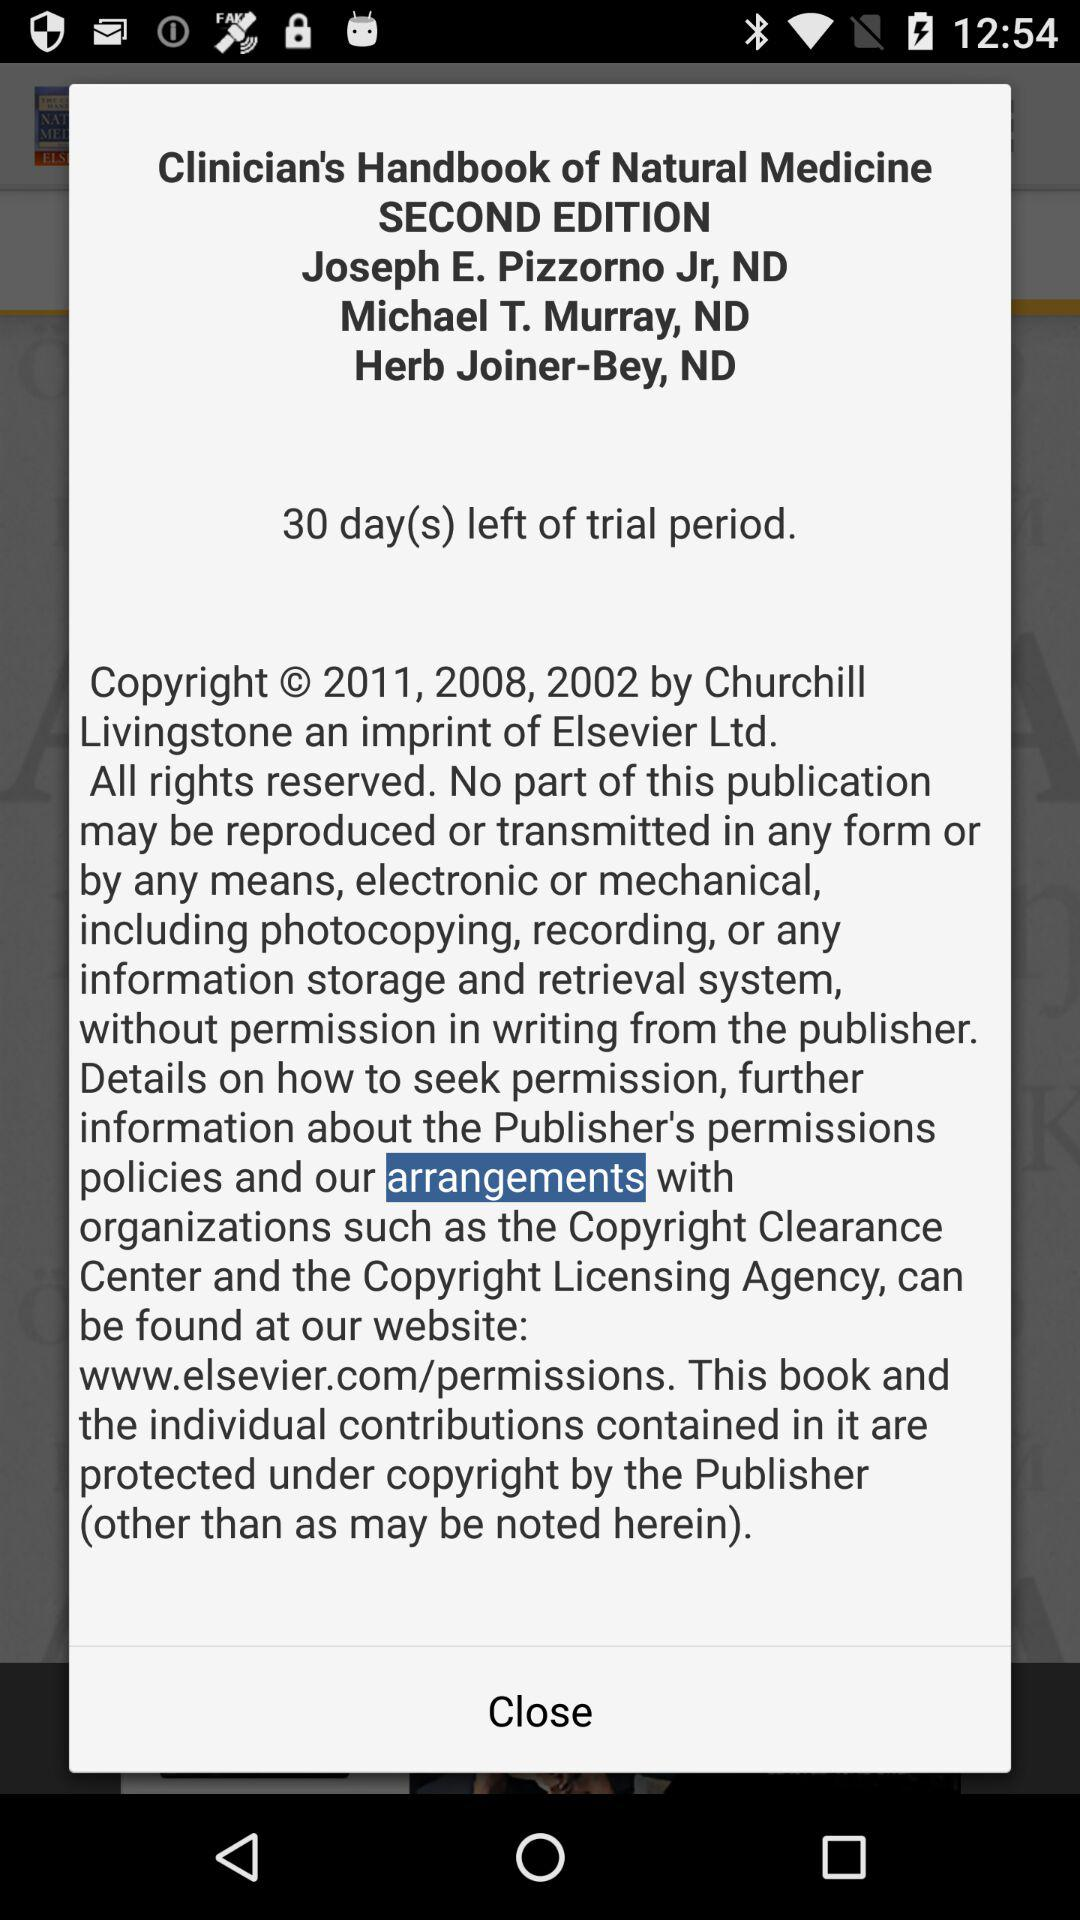How many days are left of the trial period? The number of days is 30. 